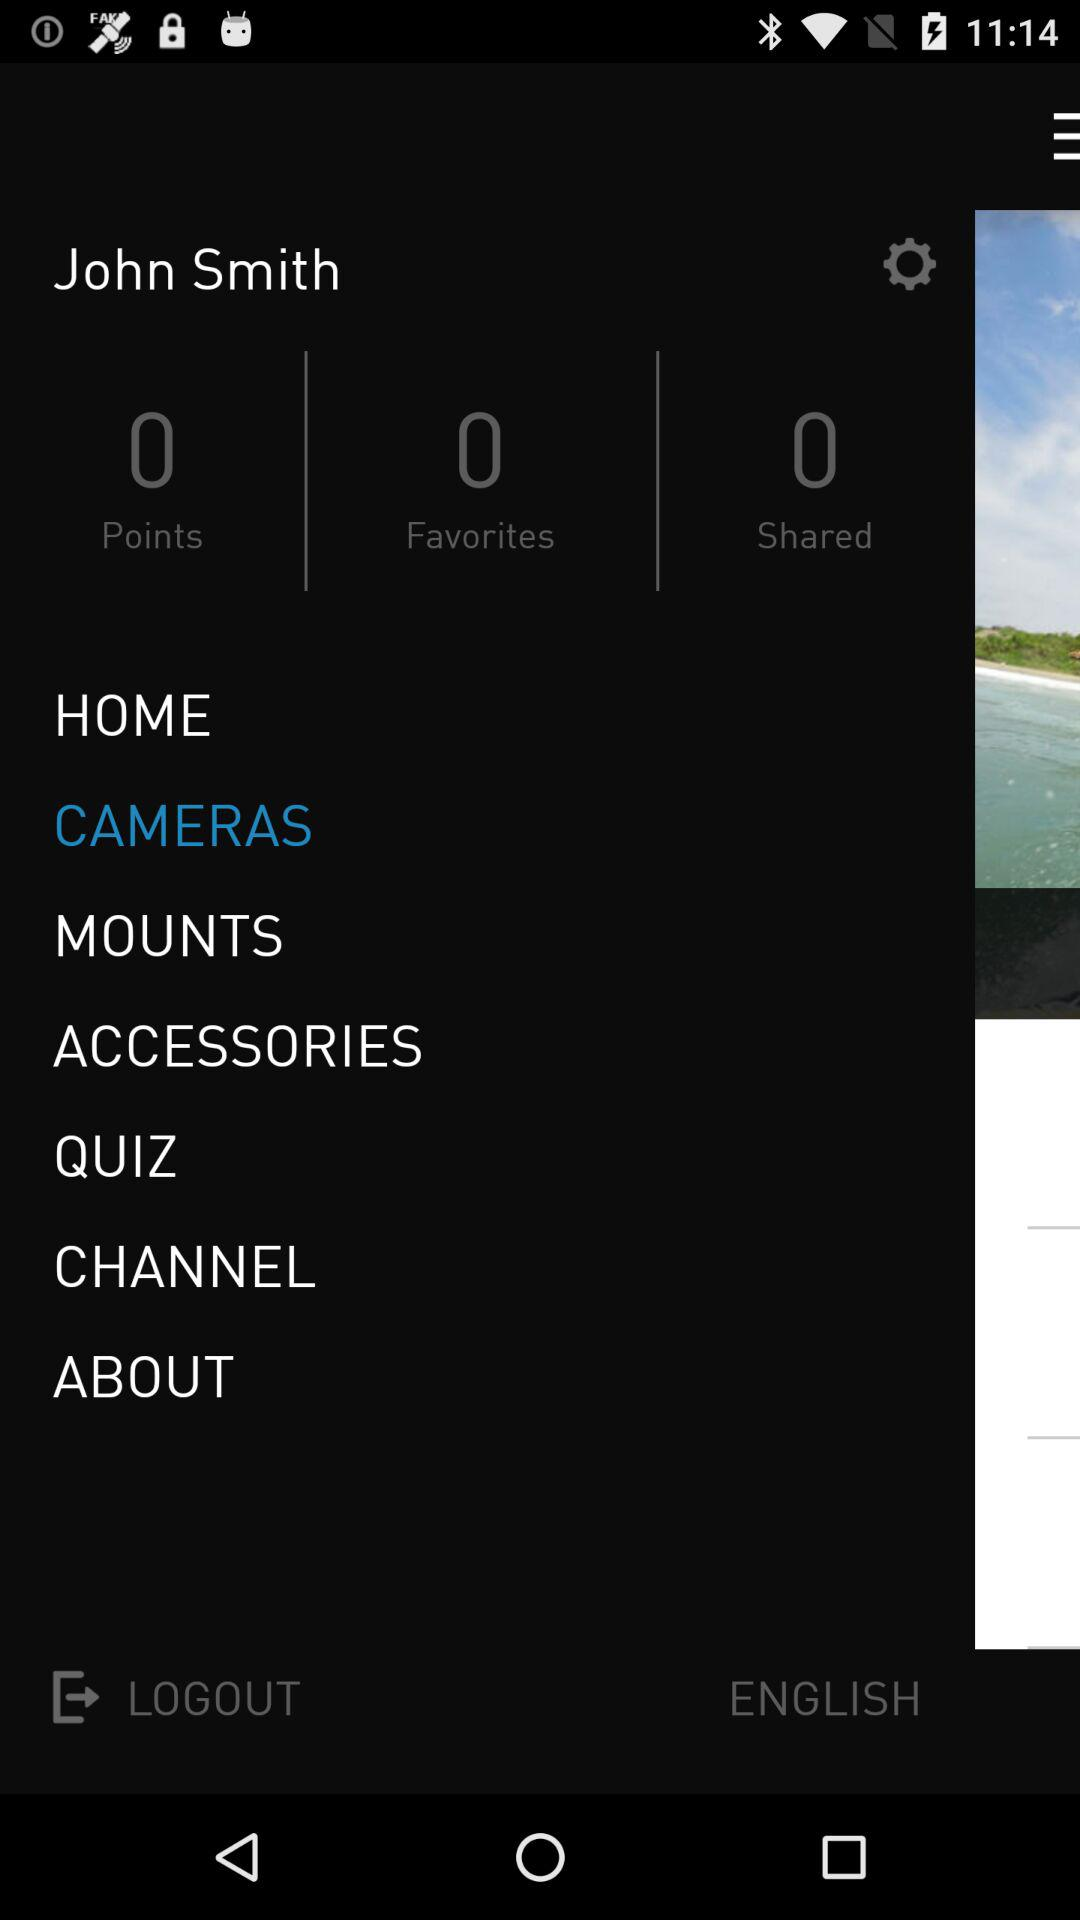How many points are there? There are 0 points. 